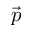<formula> <loc_0><loc_0><loc_500><loc_500>\vec { p }</formula> 